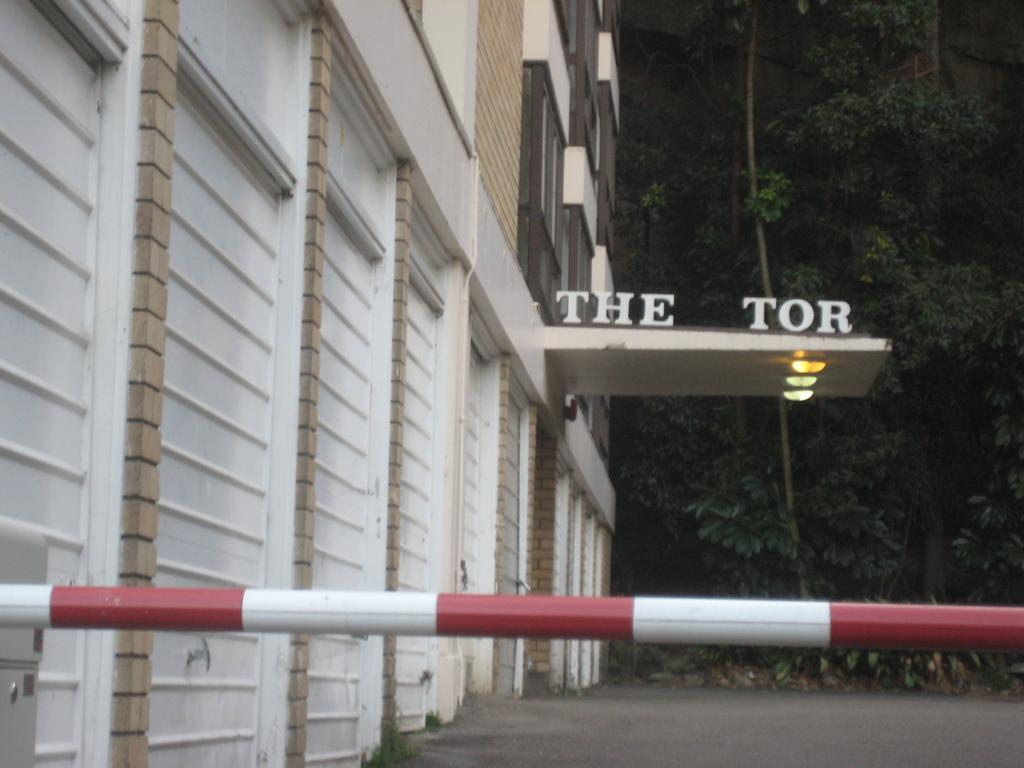What is the main object in the image? There is a pole in the image. What structure is located on the left side of the image? There is a building on the left side of the image. What is written or displayed on the building? There is text on the building. What can be seen in the background of the image? There are trees in the background of the image. Can you tell me how many books are stacked on the pole in the image? There are no books present in the image, and the pole is not used for stacking books. 